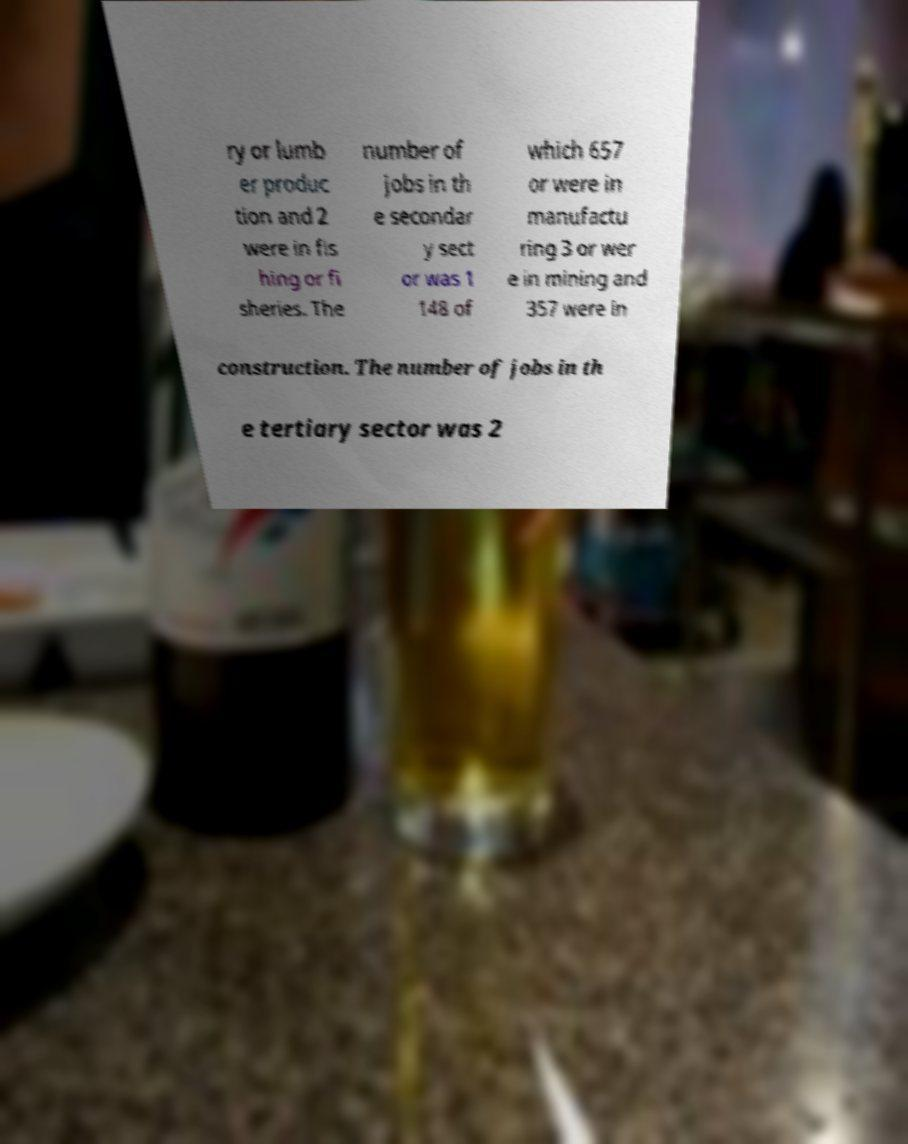For documentation purposes, I need the text within this image transcribed. Could you provide that? ry or lumb er produc tion and 2 were in fis hing or fi sheries. The number of jobs in th e secondar y sect or was 1 148 of which 657 or were in manufactu ring 3 or wer e in mining and 357 were in construction. The number of jobs in th e tertiary sector was 2 